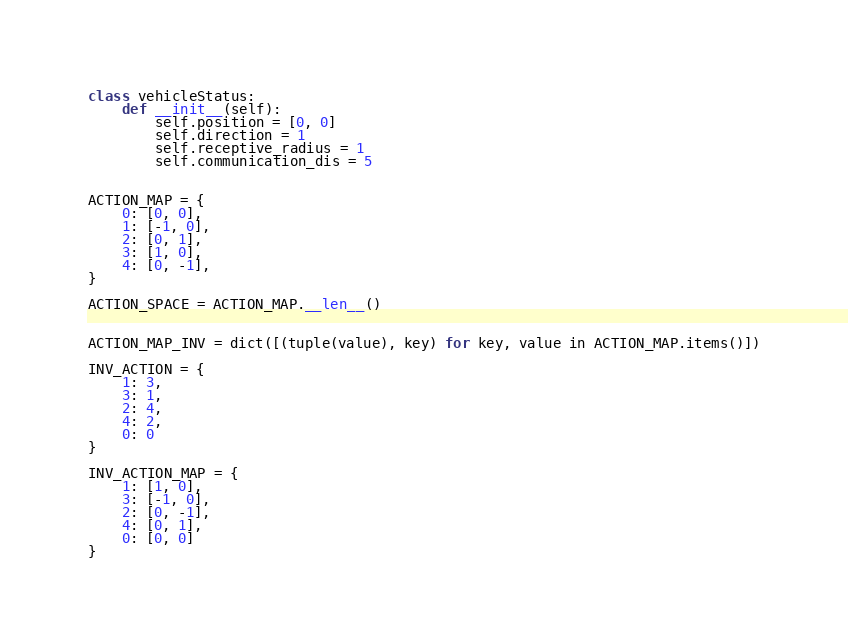Convert code to text. <code><loc_0><loc_0><loc_500><loc_500><_Python_>
class vehicleStatus:
    def __init__(self):
        self.position = [0, 0]
        self.direction = 1
        self.receptive_radius = 1
        self.communication_dis = 5


ACTION_MAP = {
    0: [0, 0],
    1: [-1, 0],
    2: [0, 1],
    3: [1, 0],
    4: [0, -1],
}

ACTION_SPACE = ACTION_MAP.__len__()


ACTION_MAP_INV = dict([(tuple(value), key) for key, value in ACTION_MAP.items()])

INV_ACTION = {
    1: 3,
    3: 1,
    2: 4,
    4: 2,
    0: 0
}

INV_ACTION_MAP = {
    1: [1, 0],
    3: [-1, 0],
    2: [0, -1],
    4: [0, 1],
    0: [0, 0]
}
</code> 